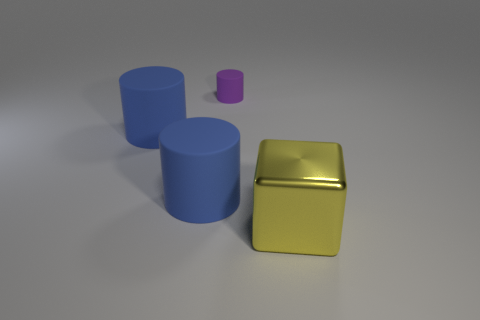Add 3 big rubber objects. How many objects exist? 7 Subtract all cylinders. How many objects are left? 1 Add 2 small purple things. How many small purple things are left? 3 Add 2 tiny cylinders. How many tiny cylinders exist? 3 Subtract 0 cyan balls. How many objects are left? 4 Subtract all small things. Subtract all red metal balls. How many objects are left? 3 